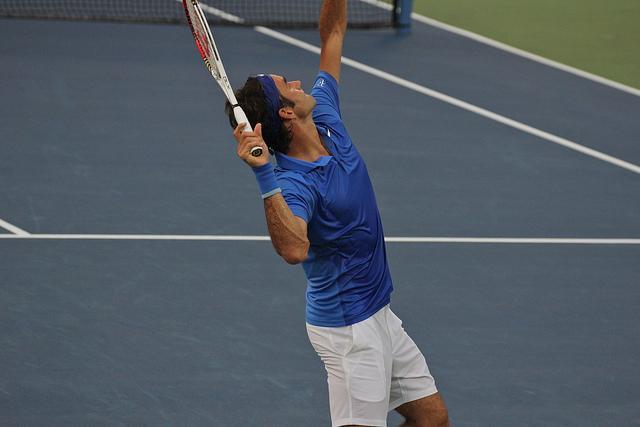How many people can you see?
Give a very brief answer. 1. 